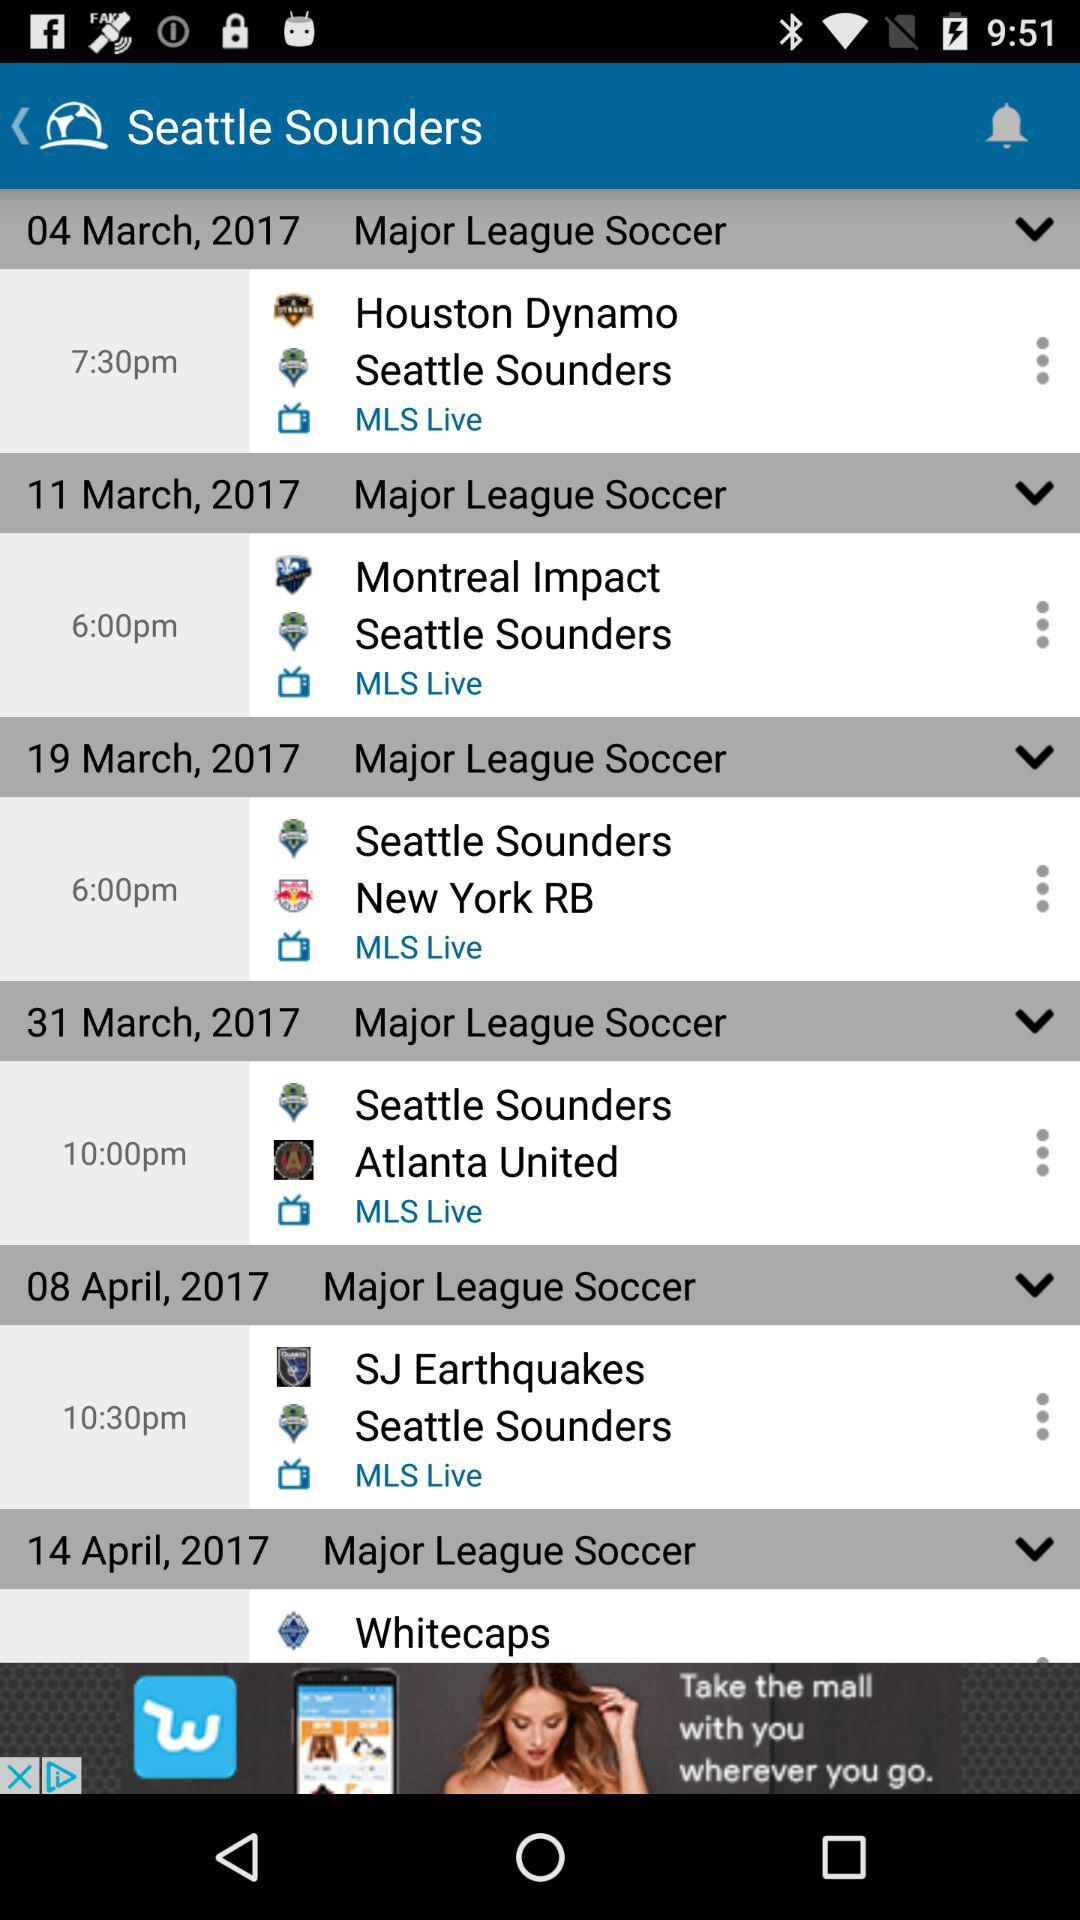When will the match between the "Houston Dynamo" and the "Seattle Sounders" be played in "Major League Soccer"? The match between the "Houston Dynamo" and the "Seattle Sounders" will be played on March 4, 2017 at 7:30 pm. 